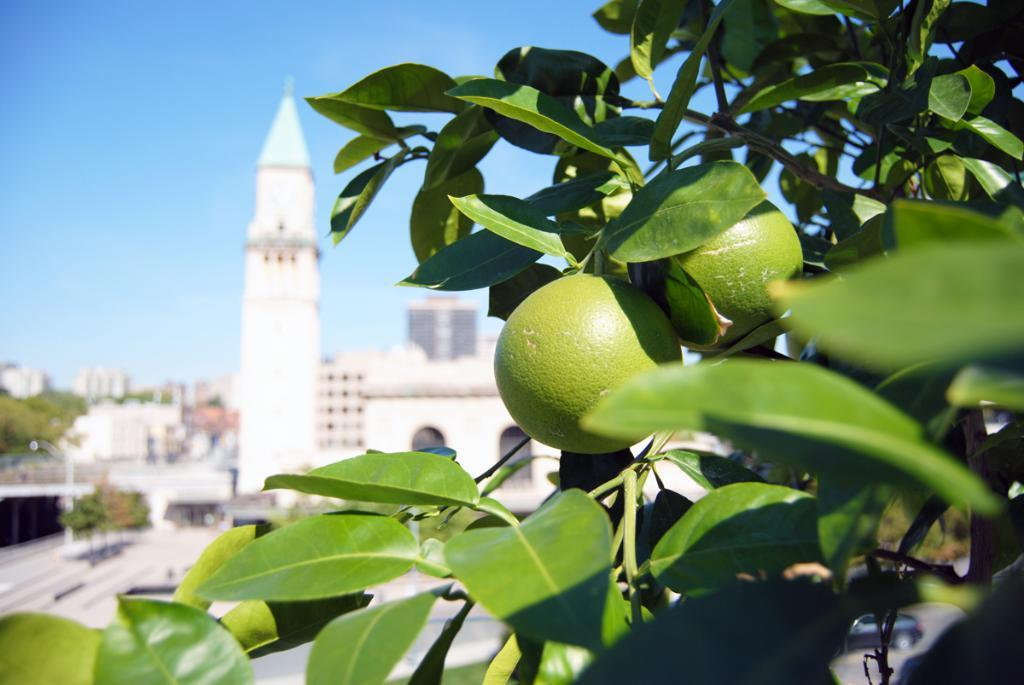What type of vegetation can be seen on the right side of the image? There are plants on the right side of the image. What part of the plants can be seen in the image? Leaves are present in the image. What can be harvested from the plants in the image? Fruits are visible in the image. What type of structures can be seen in the background of the image? There are buildings and a steeple visible in the background of the image. What natural elements can be seen in the background of the image? Trees and the sky are visible in the background of the image. What type of lipstick is the visitor wearing in the image? There is no visitor present in the image, and therefore no lipstick can be observed. How many bananas are hanging from the trees in the image? There is no mention of bananas in the image; the plants are described as having fruits, but the specific type of fruit is not identified. 